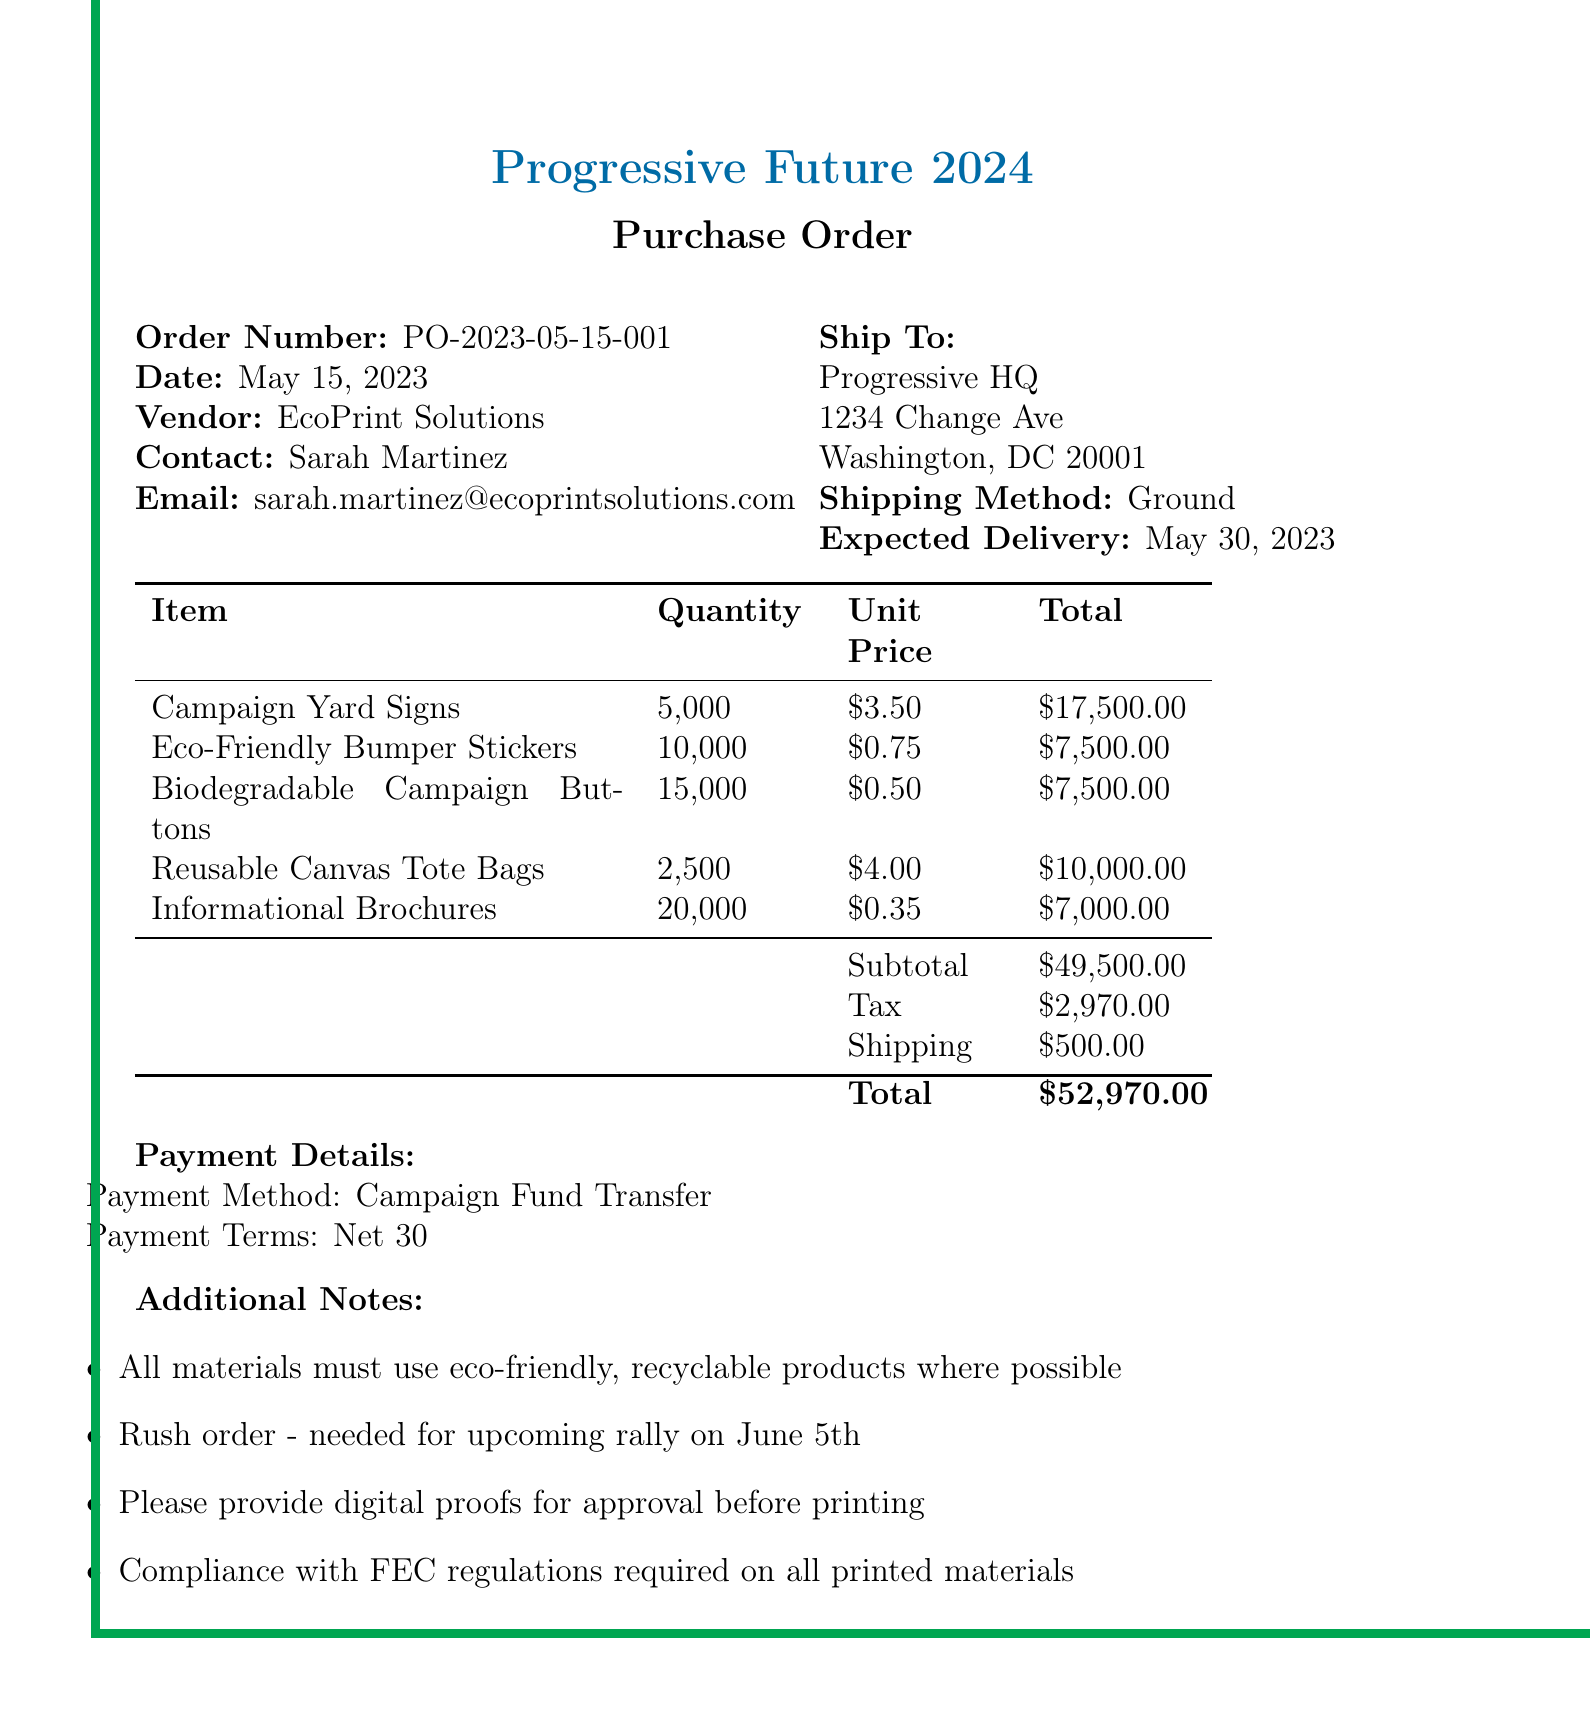What is the order number? The order number is a unique identifier for the transaction, which is specified in the document as PO-2023-05-15-001.
Answer: PO-2023-05-15-001 Who is the contact person for the order? The contact person is the individual responsible for communications regarding the order, listed as Sarah Martinez.
Answer: Sarah Martinez What is the total price of the order? The total price represents the final amount payable for the order, including all costs, which is stated as $52,970.
Answer: $52,970 How many Informational Brochures are being ordered? The quantity indicates how many of the specific item are ordered, which, for Informational Brochures, is 20,000.
Answer: 20,000 What is the expected delivery date? The expected delivery date informs when the order is anticipated to arrive, specified as May 30, 2023.
Answer: May 30, 2023 What is the payment method listed in the document? The payment method details how payment will be processed for the transaction, which is indicated as Campaign Fund Transfer.
Answer: Campaign Fund Transfer Why is the order considered a rush order? A rush order requires expedited production and shipping due to impending events, in this case, needed for an upcoming rally on June 5th.
Answer: Needed for upcoming rally on June 5th What type of printing materials is emphasized for this order? The document stresses the importance of using environmentally friendly materials throughout the printing process.
Answer: Eco-friendly, recyclable products What does the payment terms of "Net 30" indicate? Payment terms specify the timeframe in which payment is to be made, with "Net 30" meaning payment is due within 30 days.
Answer: Net 30 